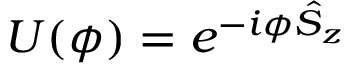Convert formula to latex. <formula><loc_0><loc_0><loc_500><loc_500>U ( \phi ) = e ^ { - i \phi \hat { S } _ { z } }</formula> 